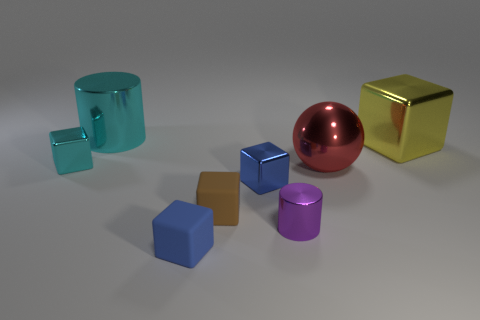What materials do the objects appear to be made from? The objects appear to be rendered with different materials. The large ball and the cube on the right seem to have a metallic finish, possibly suggesting a material like polished metal. The cubes and cylinders have a matte finish that could imply a plastic or painted wood material. 